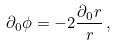<formula> <loc_0><loc_0><loc_500><loc_500>\partial _ { 0 } \phi = - 2 \frac { \partial _ { 0 } r } { r } \, ,</formula> 